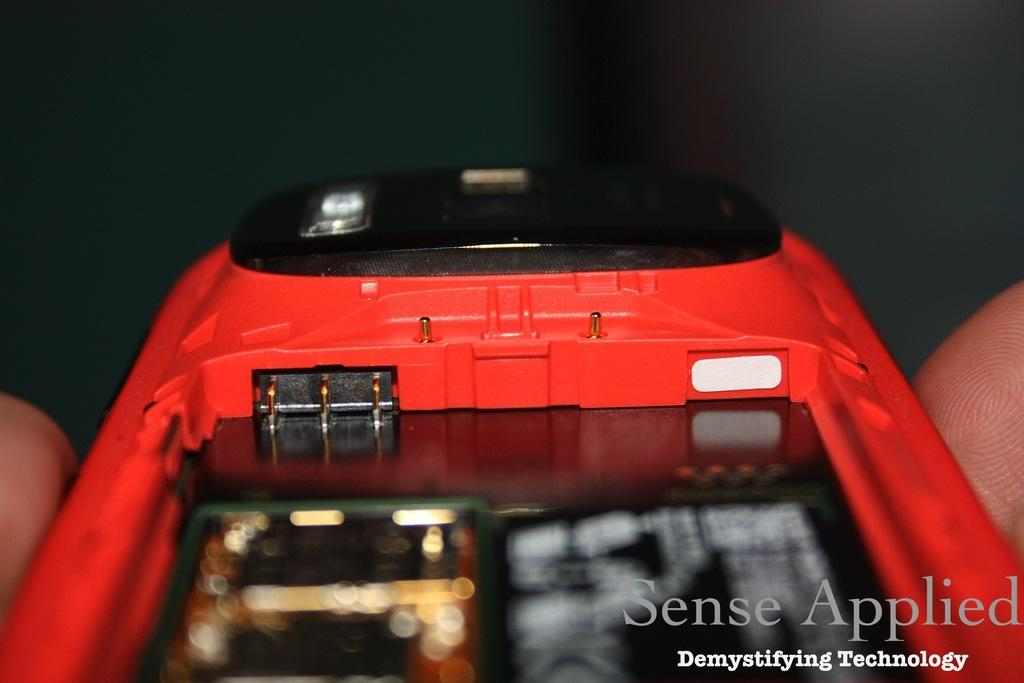<image>
Render a clear and concise summary of the photo. The rear of cell phone with a battery cover off with overlaid text saying"Sense Appiled 